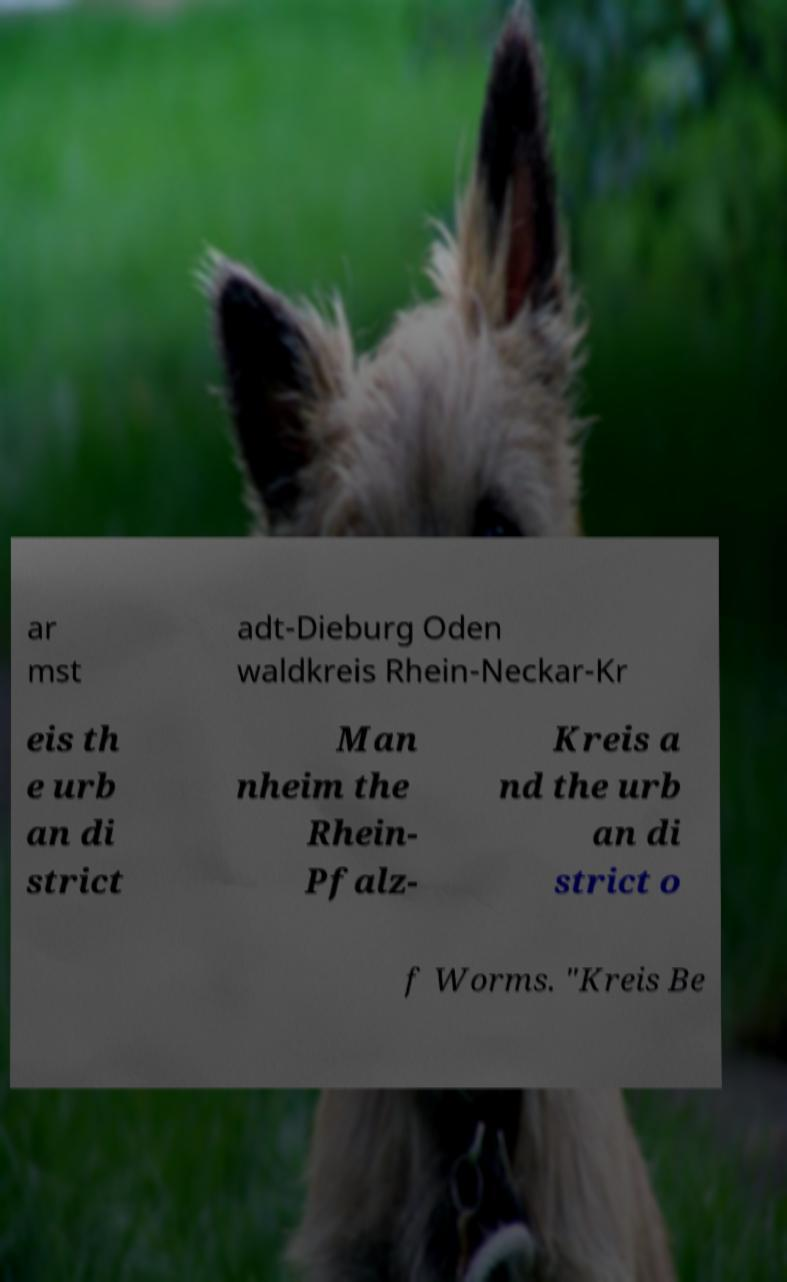Can you accurately transcribe the text from the provided image for me? ar mst adt-Dieburg Oden waldkreis Rhein-Neckar-Kr eis th e urb an di strict Man nheim the Rhein- Pfalz- Kreis a nd the urb an di strict o f Worms. "Kreis Be 